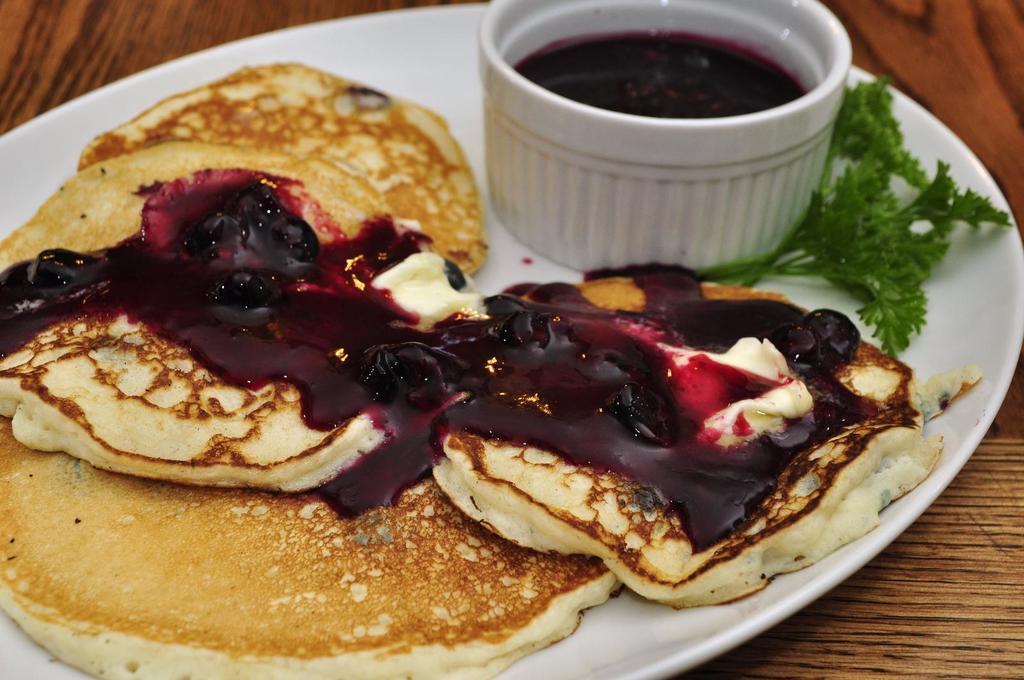Could you give a brief overview of what you see in this image? In this picture there is a plate in the center of the image, which contains food items in it and there is a bowl in the plate. 